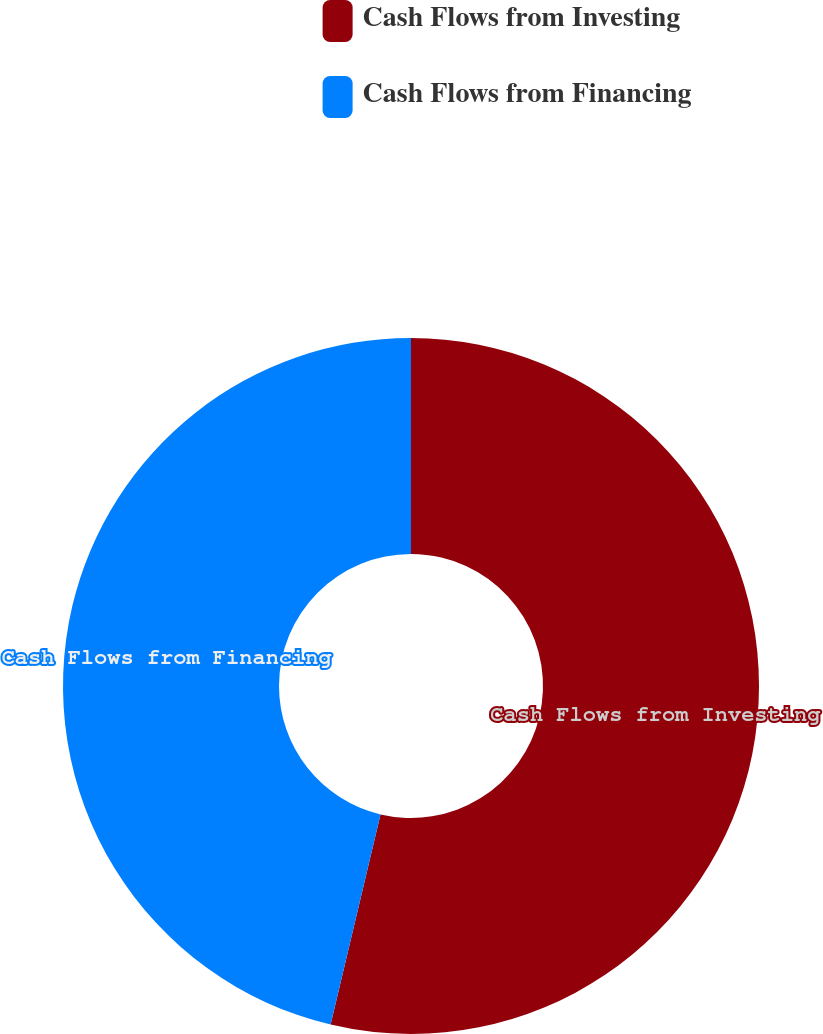<chart> <loc_0><loc_0><loc_500><loc_500><pie_chart><fcel>Cash Flows from Investing<fcel>Cash Flows from Financing<nl><fcel>53.71%<fcel>46.29%<nl></chart> 